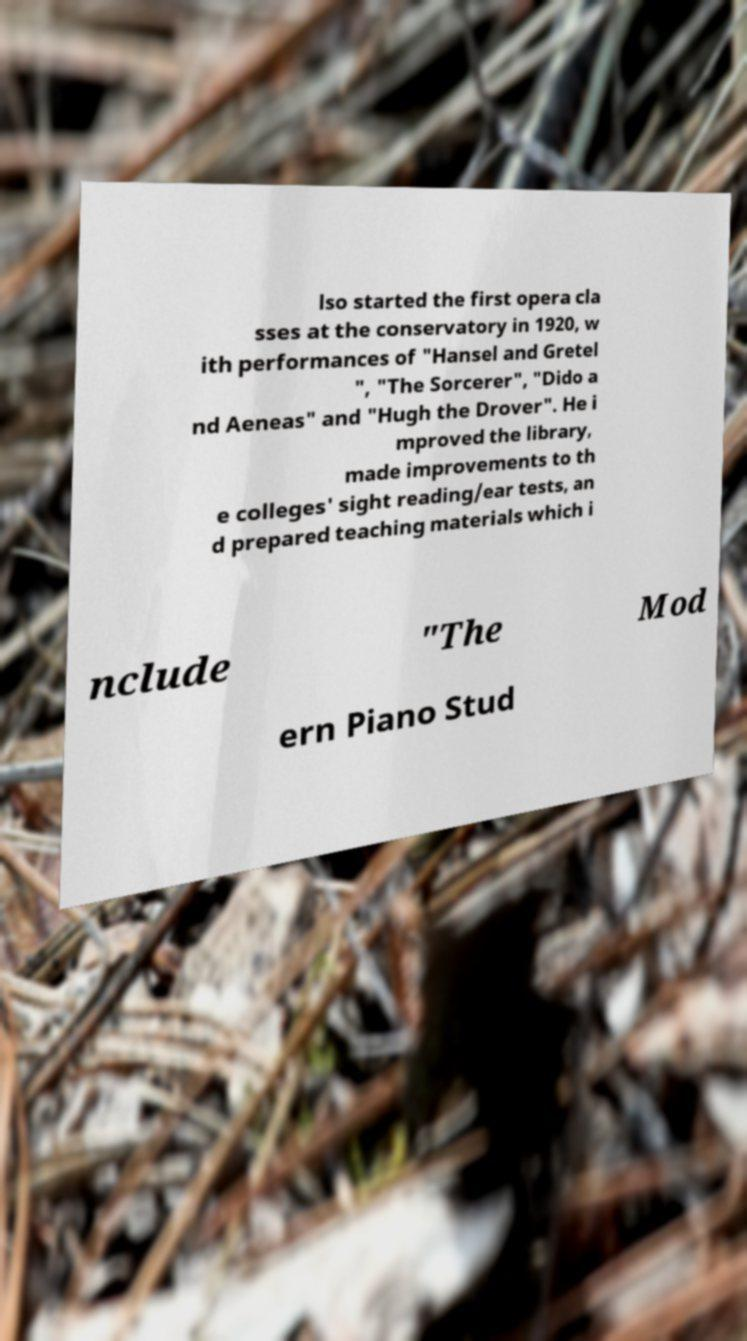Can you accurately transcribe the text from the provided image for me? lso started the first opera cla sses at the conservatory in 1920, w ith performances of "Hansel and Gretel ", "The Sorcerer", "Dido a nd Aeneas" and "Hugh the Drover". He i mproved the library, made improvements to th e colleges' sight reading/ear tests, an d prepared teaching materials which i nclude "The Mod ern Piano Stud 